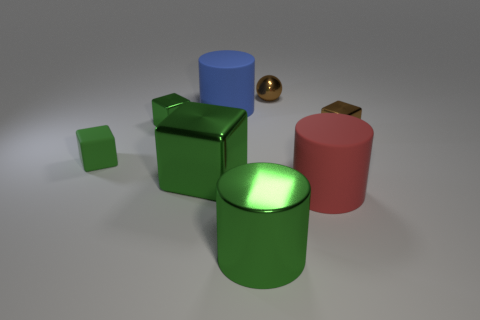What number of other things are the same color as the shiny cylinder?
Offer a terse response. 3. There is a green metal block that is behind the matte cube; does it have the same size as the green rubber object?
Your answer should be very brief. Yes. Is the material of the cylinder that is in front of the big red rubber cylinder the same as the cylinder to the right of the tiny metallic sphere?
Keep it short and to the point. No. Is there another thing that has the same size as the red matte object?
Your response must be concise. Yes. There is a brown object to the right of the small brown metallic ball to the left of the brown metal thing that is right of the tiny brown metal sphere; what shape is it?
Give a very brief answer. Cube. Is the number of cylinders behind the big blue cylinder greater than the number of small cyan spheres?
Keep it short and to the point. No. Are there any tiny yellow matte things of the same shape as the blue rubber object?
Make the answer very short. No. Do the brown sphere and the block right of the blue thing have the same material?
Your answer should be very brief. Yes. The small matte block is what color?
Ensure brevity in your answer.  Green. There is a green thing in front of the big cylinder that is right of the green cylinder; what number of small blocks are left of it?
Keep it short and to the point. 2. 